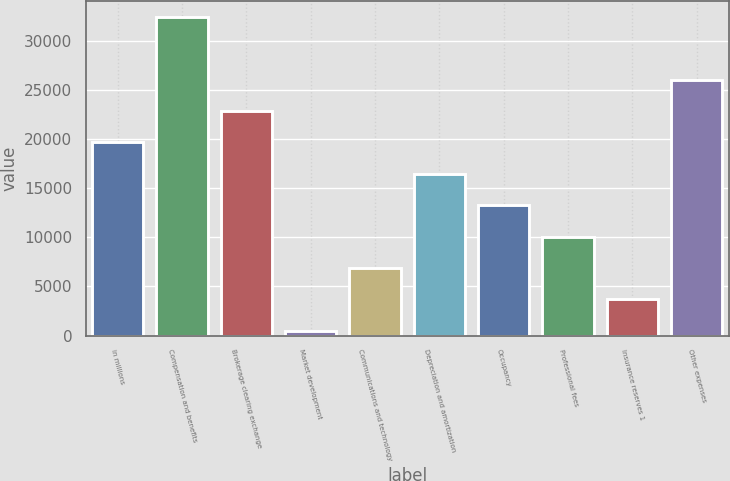Convert chart. <chart><loc_0><loc_0><loc_500><loc_500><bar_chart><fcel>in millions<fcel>Compensation and benefits<fcel>Brokerage clearing exchange<fcel>Market development<fcel>Communications and technology<fcel>Depreciation and amortization<fcel>Occupancy<fcel>Professional fees<fcel>Insurance reserves 1<fcel>Other expenses<nl><fcel>19643.6<fcel>32400<fcel>22832.7<fcel>509<fcel>6887.2<fcel>16454.5<fcel>13265.4<fcel>10076.3<fcel>3698.1<fcel>26021.8<nl></chart> 